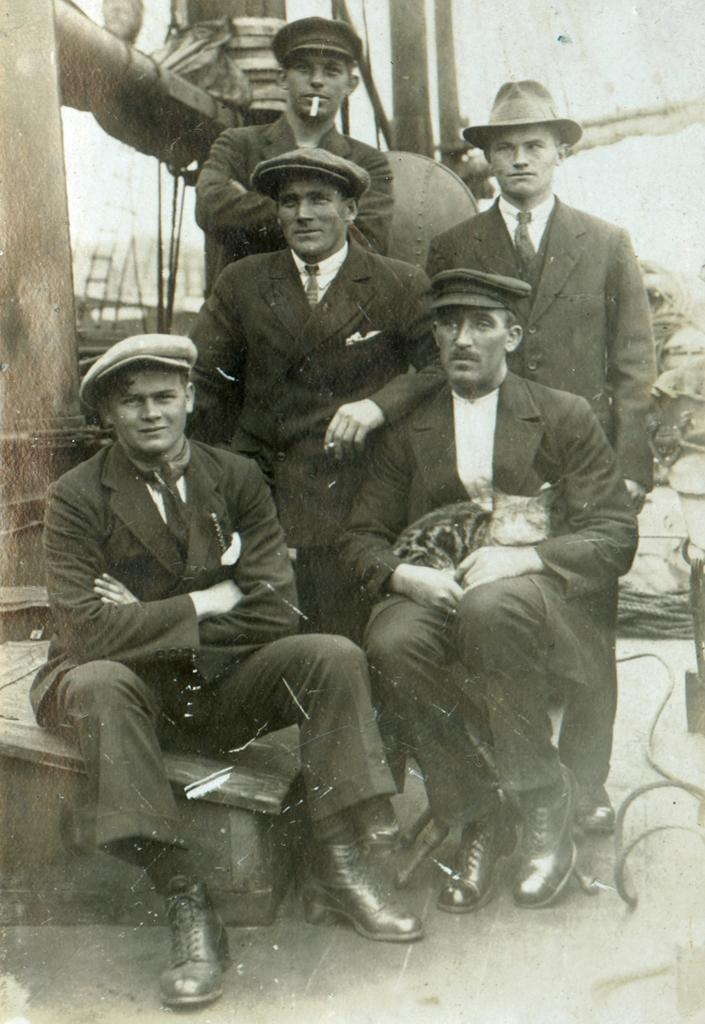What are the people in the image doing? There are people standing and seated in the image. How are the people dressed in the image? All the people in the image are wearing caps on their heads. What type of leaf can be seen falling in the image? There is no leaf present in the image; it only features people standing and seated, all wearing caps. 